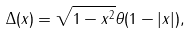<formula> <loc_0><loc_0><loc_500><loc_500>\Delta ( x ) = \sqrt { 1 - x ^ { 2 } } \theta ( 1 - | x | ) ,</formula> 